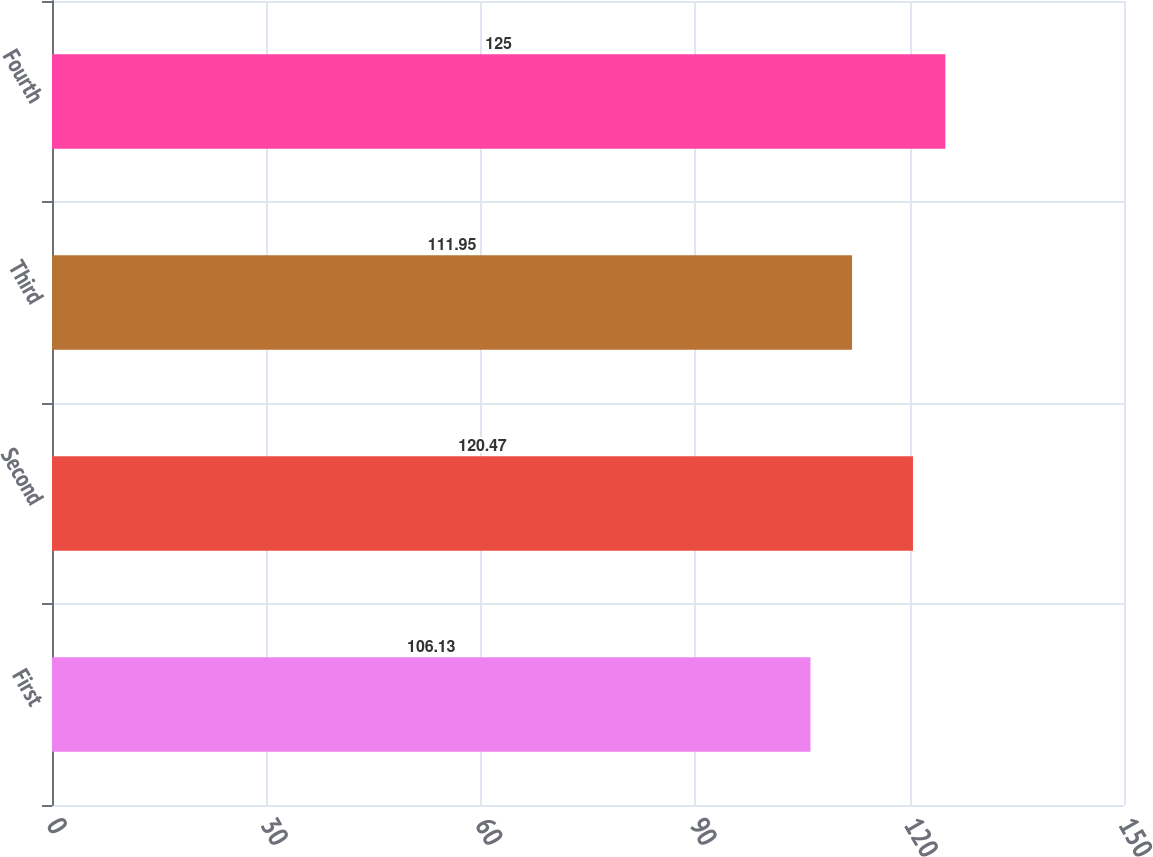Convert chart. <chart><loc_0><loc_0><loc_500><loc_500><bar_chart><fcel>First<fcel>Second<fcel>Third<fcel>Fourth<nl><fcel>106.13<fcel>120.47<fcel>111.95<fcel>125<nl></chart> 